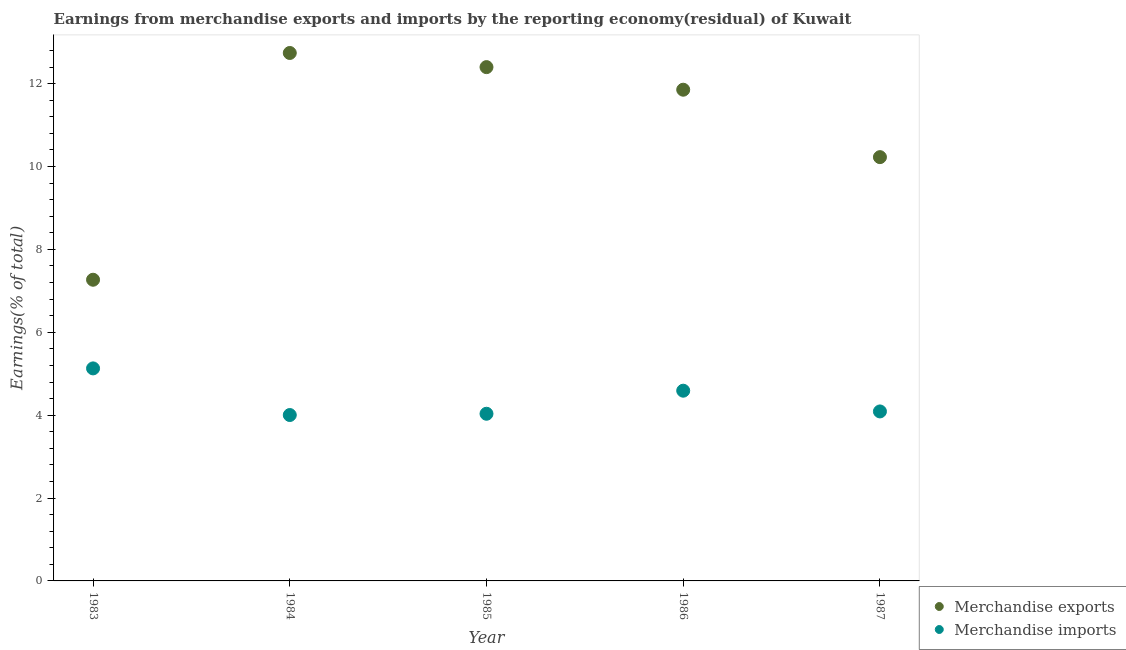What is the earnings from merchandise imports in 1984?
Make the answer very short. 4. Across all years, what is the maximum earnings from merchandise imports?
Your answer should be compact. 5.13. Across all years, what is the minimum earnings from merchandise imports?
Give a very brief answer. 4. In which year was the earnings from merchandise imports maximum?
Provide a succinct answer. 1983. In which year was the earnings from merchandise exports minimum?
Ensure brevity in your answer.  1983. What is the total earnings from merchandise exports in the graph?
Provide a succinct answer. 54.49. What is the difference between the earnings from merchandise imports in 1983 and that in 1987?
Ensure brevity in your answer.  1.04. What is the difference between the earnings from merchandise exports in 1986 and the earnings from merchandise imports in 1984?
Your answer should be very brief. 7.85. What is the average earnings from merchandise exports per year?
Your answer should be very brief. 10.9. In the year 1986, what is the difference between the earnings from merchandise exports and earnings from merchandise imports?
Keep it short and to the point. 7.26. In how many years, is the earnings from merchandise exports greater than 4.4 %?
Your response must be concise. 5. What is the ratio of the earnings from merchandise exports in 1983 to that in 1986?
Keep it short and to the point. 0.61. Is the earnings from merchandise exports in 1984 less than that in 1987?
Your answer should be compact. No. Is the difference between the earnings from merchandise imports in 1983 and 1984 greater than the difference between the earnings from merchandise exports in 1983 and 1984?
Provide a succinct answer. Yes. What is the difference between the highest and the second highest earnings from merchandise exports?
Ensure brevity in your answer.  0.34. What is the difference between the highest and the lowest earnings from merchandise exports?
Ensure brevity in your answer.  5.47. Is the sum of the earnings from merchandise exports in 1985 and 1986 greater than the maximum earnings from merchandise imports across all years?
Your answer should be very brief. Yes. Does the earnings from merchandise exports monotonically increase over the years?
Provide a short and direct response. No. Is the earnings from merchandise imports strictly greater than the earnings from merchandise exports over the years?
Your answer should be very brief. No. Is the earnings from merchandise exports strictly less than the earnings from merchandise imports over the years?
Make the answer very short. No. How many years are there in the graph?
Provide a short and direct response. 5. What is the difference between two consecutive major ticks on the Y-axis?
Your answer should be very brief. 2. Does the graph contain any zero values?
Make the answer very short. No. Does the graph contain grids?
Your response must be concise. No. How many legend labels are there?
Ensure brevity in your answer.  2. What is the title of the graph?
Make the answer very short. Earnings from merchandise exports and imports by the reporting economy(residual) of Kuwait. What is the label or title of the Y-axis?
Ensure brevity in your answer.  Earnings(% of total). What is the Earnings(% of total) of Merchandise exports in 1983?
Make the answer very short. 7.27. What is the Earnings(% of total) of Merchandise imports in 1983?
Offer a terse response. 5.13. What is the Earnings(% of total) in Merchandise exports in 1984?
Offer a terse response. 12.74. What is the Earnings(% of total) in Merchandise imports in 1984?
Give a very brief answer. 4. What is the Earnings(% of total) of Merchandise exports in 1985?
Provide a succinct answer. 12.4. What is the Earnings(% of total) in Merchandise imports in 1985?
Keep it short and to the point. 4.03. What is the Earnings(% of total) in Merchandise exports in 1986?
Keep it short and to the point. 11.85. What is the Earnings(% of total) in Merchandise imports in 1986?
Provide a short and direct response. 4.59. What is the Earnings(% of total) in Merchandise exports in 1987?
Give a very brief answer. 10.23. What is the Earnings(% of total) in Merchandise imports in 1987?
Make the answer very short. 4.09. Across all years, what is the maximum Earnings(% of total) in Merchandise exports?
Offer a terse response. 12.74. Across all years, what is the maximum Earnings(% of total) of Merchandise imports?
Your answer should be compact. 5.13. Across all years, what is the minimum Earnings(% of total) of Merchandise exports?
Provide a succinct answer. 7.27. Across all years, what is the minimum Earnings(% of total) in Merchandise imports?
Make the answer very short. 4. What is the total Earnings(% of total) of Merchandise exports in the graph?
Your answer should be very brief. 54.49. What is the total Earnings(% of total) in Merchandise imports in the graph?
Keep it short and to the point. 21.85. What is the difference between the Earnings(% of total) of Merchandise exports in 1983 and that in 1984?
Provide a succinct answer. -5.47. What is the difference between the Earnings(% of total) in Merchandise imports in 1983 and that in 1984?
Make the answer very short. 1.13. What is the difference between the Earnings(% of total) of Merchandise exports in 1983 and that in 1985?
Give a very brief answer. -5.13. What is the difference between the Earnings(% of total) in Merchandise imports in 1983 and that in 1985?
Provide a succinct answer. 1.09. What is the difference between the Earnings(% of total) in Merchandise exports in 1983 and that in 1986?
Keep it short and to the point. -4.59. What is the difference between the Earnings(% of total) of Merchandise imports in 1983 and that in 1986?
Ensure brevity in your answer.  0.54. What is the difference between the Earnings(% of total) in Merchandise exports in 1983 and that in 1987?
Give a very brief answer. -2.96. What is the difference between the Earnings(% of total) in Merchandise imports in 1983 and that in 1987?
Provide a succinct answer. 1.04. What is the difference between the Earnings(% of total) in Merchandise exports in 1984 and that in 1985?
Ensure brevity in your answer.  0.34. What is the difference between the Earnings(% of total) of Merchandise imports in 1984 and that in 1985?
Make the answer very short. -0.03. What is the difference between the Earnings(% of total) in Merchandise exports in 1984 and that in 1986?
Provide a succinct answer. 0.89. What is the difference between the Earnings(% of total) of Merchandise imports in 1984 and that in 1986?
Your response must be concise. -0.59. What is the difference between the Earnings(% of total) of Merchandise exports in 1984 and that in 1987?
Keep it short and to the point. 2.51. What is the difference between the Earnings(% of total) in Merchandise imports in 1984 and that in 1987?
Provide a succinct answer. -0.09. What is the difference between the Earnings(% of total) of Merchandise exports in 1985 and that in 1986?
Offer a very short reply. 0.55. What is the difference between the Earnings(% of total) of Merchandise imports in 1985 and that in 1986?
Offer a very short reply. -0.56. What is the difference between the Earnings(% of total) in Merchandise exports in 1985 and that in 1987?
Offer a very short reply. 2.17. What is the difference between the Earnings(% of total) of Merchandise imports in 1985 and that in 1987?
Provide a short and direct response. -0.06. What is the difference between the Earnings(% of total) of Merchandise exports in 1986 and that in 1987?
Your answer should be very brief. 1.63. What is the difference between the Earnings(% of total) of Merchandise imports in 1986 and that in 1987?
Keep it short and to the point. 0.5. What is the difference between the Earnings(% of total) of Merchandise exports in 1983 and the Earnings(% of total) of Merchandise imports in 1984?
Offer a very short reply. 3.26. What is the difference between the Earnings(% of total) in Merchandise exports in 1983 and the Earnings(% of total) in Merchandise imports in 1985?
Offer a very short reply. 3.23. What is the difference between the Earnings(% of total) in Merchandise exports in 1983 and the Earnings(% of total) in Merchandise imports in 1986?
Offer a very short reply. 2.68. What is the difference between the Earnings(% of total) in Merchandise exports in 1983 and the Earnings(% of total) in Merchandise imports in 1987?
Keep it short and to the point. 3.18. What is the difference between the Earnings(% of total) in Merchandise exports in 1984 and the Earnings(% of total) in Merchandise imports in 1985?
Provide a succinct answer. 8.71. What is the difference between the Earnings(% of total) of Merchandise exports in 1984 and the Earnings(% of total) of Merchandise imports in 1986?
Offer a very short reply. 8.15. What is the difference between the Earnings(% of total) in Merchandise exports in 1984 and the Earnings(% of total) in Merchandise imports in 1987?
Offer a very short reply. 8.65. What is the difference between the Earnings(% of total) in Merchandise exports in 1985 and the Earnings(% of total) in Merchandise imports in 1986?
Your response must be concise. 7.81. What is the difference between the Earnings(% of total) in Merchandise exports in 1985 and the Earnings(% of total) in Merchandise imports in 1987?
Offer a terse response. 8.31. What is the difference between the Earnings(% of total) of Merchandise exports in 1986 and the Earnings(% of total) of Merchandise imports in 1987?
Provide a short and direct response. 7.76. What is the average Earnings(% of total) of Merchandise exports per year?
Offer a very short reply. 10.9. What is the average Earnings(% of total) of Merchandise imports per year?
Make the answer very short. 4.37. In the year 1983, what is the difference between the Earnings(% of total) in Merchandise exports and Earnings(% of total) in Merchandise imports?
Ensure brevity in your answer.  2.14. In the year 1984, what is the difference between the Earnings(% of total) of Merchandise exports and Earnings(% of total) of Merchandise imports?
Offer a very short reply. 8.74. In the year 1985, what is the difference between the Earnings(% of total) in Merchandise exports and Earnings(% of total) in Merchandise imports?
Your answer should be very brief. 8.37. In the year 1986, what is the difference between the Earnings(% of total) in Merchandise exports and Earnings(% of total) in Merchandise imports?
Ensure brevity in your answer.  7.26. In the year 1987, what is the difference between the Earnings(% of total) of Merchandise exports and Earnings(% of total) of Merchandise imports?
Keep it short and to the point. 6.14. What is the ratio of the Earnings(% of total) of Merchandise exports in 1983 to that in 1984?
Ensure brevity in your answer.  0.57. What is the ratio of the Earnings(% of total) of Merchandise imports in 1983 to that in 1984?
Make the answer very short. 1.28. What is the ratio of the Earnings(% of total) of Merchandise exports in 1983 to that in 1985?
Your answer should be compact. 0.59. What is the ratio of the Earnings(% of total) in Merchandise imports in 1983 to that in 1985?
Keep it short and to the point. 1.27. What is the ratio of the Earnings(% of total) in Merchandise exports in 1983 to that in 1986?
Offer a very short reply. 0.61. What is the ratio of the Earnings(% of total) in Merchandise imports in 1983 to that in 1986?
Offer a terse response. 1.12. What is the ratio of the Earnings(% of total) in Merchandise exports in 1983 to that in 1987?
Your answer should be very brief. 0.71. What is the ratio of the Earnings(% of total) in Merchandise imports in 1983 to that in 1987?
Give a very brief answer. 1.25. What is the ratio of the Earnings(% of total) in Merchandise exports in 1984 to that in 1985?
Keep it short and to the point. 1.03. What is the ratio of the Earnings(% of total) in Merchandise exports in 1984 to that in 1986?
Provide a short and direct response. 1.07. What is the ratio of the Earnings(% of total) in Merchandise imports in 1984 to that in 1986?
Your answer should be compact. 0.87. What is the ratio of the Earnings(% of total) in Merchandise exports in 1984 to that in 1987?
Keep it short and to the point. 1.25. What is the ratio of the Earnings(% of total) of Merchandise imports in 1984 to that in 1987?
Your answer should be very brief. 0.98. What is the ratio of the Earnings(% of total) in Merchandise exports in 1985 to that in 1986?
Ensure brevity in your answer.  1.05. What is the ratio of the Earnings(% of total) in Merchandise imports in 1985 to that in 1986?
Provide a succinct answer. 0.88. What is the ratio of the Earnings(% of total) of Merchandise exports in 1985 to that in 1987?
Keep it short and to the point. 1.21. What is the ratio of the Earnings(% of total) in Merchandise imports in 1985 to that in 1987?
Your response must be concise. 0.99. What is the ratio of the Earnings(% of total) in Merchandise exports in 1986 to that in 1987?
Give a very brief answer. 1.16. What is the ratio of the Earnings(% of total) of Merchandise imports in 1986 to that in 1987?
Provide a succinct answer. 1.12. What is the difference between the highest and the second highest Earnings(% of total) of Merchandise exports?
Provide a short and direct response. 0.34. What is the difference between the highest and the second highest Earnings(% of total) of Merchandise imports?
Give a very brief answer. 0.54. What is the difference between the highest and the lowest Earnings(% of total) of Merchandise exports?
Offer a very short reply. 5.47. What is the difference between the highest and the lowest Earnings(% of total) in Merchandise imports?
Make the answer very short. 1.13. 